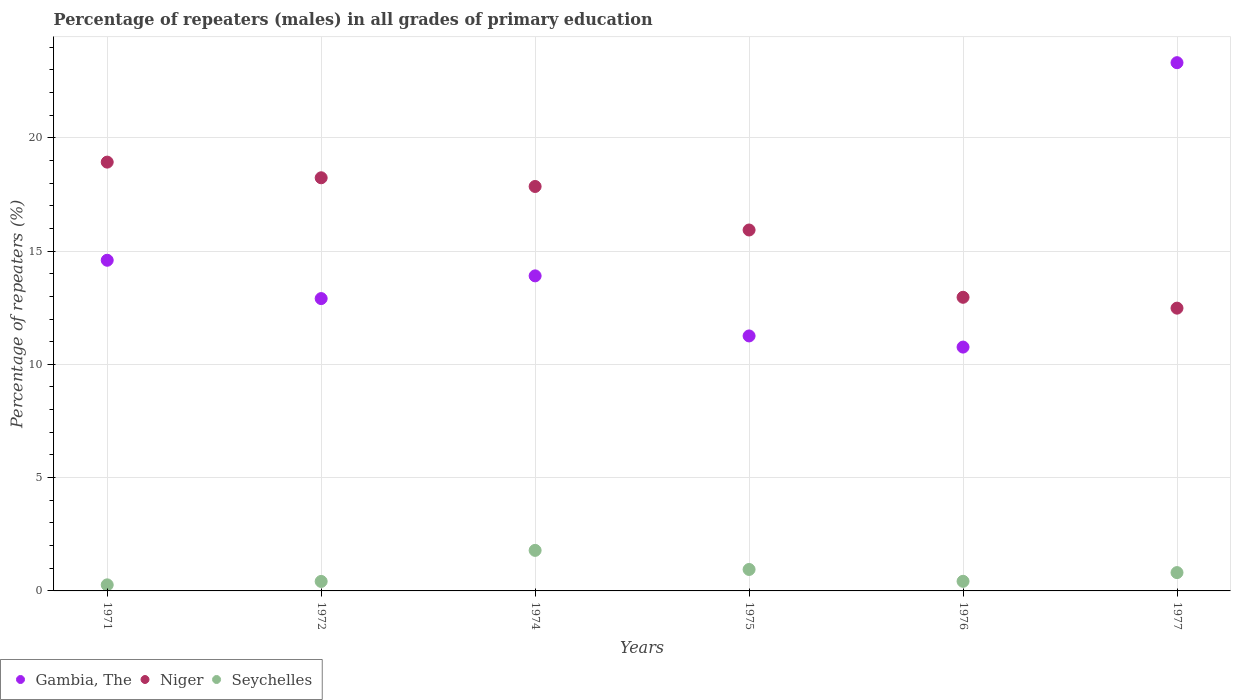What is the percentage of repeaters (males) in Gambia, The in 1976?
Your answer should be compact. 10.76. Across all years, what is the maximum percentage of repeaters (males) in Seychelles?
Ensure brevity in your answer.  1.79. Across all years, what is the minimum percentage of repeaters (males) in Seychelles?
Provide a short and direct response. 0.27. In which year was the percentage of repeaters (males) in Gambia, The maximum?
Make the answer very short. 1977. In which year was the percentage of repeaters (males) in Gambia, The minimum?
Your answer should be compact. 1976. What is the total percentage of repeaters (males) in Gambia, The in the graph?
Make the answer very short. 86.73. What is the difference between the percentage of repeaters (males) in Niger in 1971 and that in 1974?
Make the answer very short. 1.07. What is the difference between the percentage of repeaters (males) in Gambia, The in 1971 and the percentage of repeaters (males) in Niger in 1977?
Make the answer very short. 2.11. What is the average percentage of repeaters (males) in Seychelles per year?
Provide a succinct answer. 0.78. In the year 1976, what is the difference between the percentage of repeaters (males) in Niger and percentage of repeaters (males) in Seychelles?
Make the answer very short. 12.53. In how many years, is the percentage of repeaters (males) in Seychelles greater than 9 %?
Your response must be concise. 0. What is the ratio of the percentage of repeaters (males) in Seychelles in 1976 to that in 1977?
Make the answer very short. 0.52. Is the percentage of repeaters (males) in Gambia, The in 1971 less than that in 1977?
Offer a terse response. Yes. What is the difference between the highest and the second highest percentage of repeaters (males) in Gambia, The?
Keep it short and to the point. 8.72. What is the difference between the highest and the lowest percentage of repeaters (males) in Seychelles?
Offer a terse response. 1.52. In how many years, is the percentage of repeaters (males) in Seychelles greater than the average percentage of repeaters (males) in Seychelles taken over all years?
Offer a terse response. 3. Does the percentage of repeaters (males) in Niger monotonically increase over the years?
Ensure brevity in your answer.  No. How many dotlines are there?
Your response must be concise. 3. How many years are there in the graph?
Your answer should be compact. 6. What is the difference between two consecutive major ticks on the Y-axis?
Make the answer very short. 5. Are the values on the major ticks of Y-axis written in scientific E-notation?
Your answer should be compact. No. Does the graph contain grids?
Give a very brief answer. Yes. How many legend labels are there?
Give a very brief answer. 3. What is the title of the graph?
Ensure brevity in your answer.  Percentage of repeaters (males) in all grades of primary education. What is the label or title of the X-axis?
Offer a very short reply. Years. What is the label or title of the Y-axis?
Keep it short and to the point. Percentage of repeaters (%). What is the Percentage of repeaters (%) of Gambia, The in 1971?
Your answer should be very brief. 14.59. What is the Percentage of repeaters (%) of Niger in 1971?
Keep it short and to the point. 18.92. What is the Percentage of repeaters (%) of Seychelles in 1971?
Keep it short and to the point. 0.27. What is the Percentage of repeaters (%) in Gambia, The in 1972?
Your response must be concise. 12.9. What is the Percentage of repeaters (%) in Niger in 1972?
Ensure brevity in your answer.  18.23. What is the Percentage of repeaters (%) of Seychelles in 1972?
Your answer should be very brief. 0.42. What is the Percentage of repeaters (%) of Gambia, The in 1974?
Provide a succinct answer. 13.9. What is the Percentage of repeaters (%) in Niger in 1974?
Keep it short and to the point. 17.85. What is the Percentage of repeaters (%) of Seychelles in 1974?
Your answer should be compact. 1.79. What is the Percentage of repeaters (%) of Gambia, The in 1975?
Keep it short and to the point. 11.25. What is the Percentage of repeaters (%) of Niger in 1975?
Offer a very short reply. 15.93. What is the Percentage of repeaters (%) in Seychelles in 1975?
Provide a short and direct response. 0.95. What is the Percentage of repeaters (%) in Gambia, The in 1976?
Provide a short and direct response. 10.76. What is the Percentage of repeaters (%) in Niger in 1976?
Give a very brief answer. 12.96. What is the Percentage of repeaters (%) of Seychelles in 1976?
Provide a succinct answer. 0.42. What is the Percentage of repeaters (%) in Gambia, The in 1977?
Ensure brevity in your answer.  23.31. What is the Percentage of repeaters (%) in Niger in 1977?
Provide a short and direct response. 12.48. What is the Percentage of repeaters (%) in Seychelles in 1977?
Keep it short and to the point. 0.81. Across all years, what is the maximum Percentage of repeaters (%) of Gambia, The?
Your response must be concise. 23.31. Across all years, what is the maximum Percentage of repeaters (%) of Niger?
Your answer should be compact. 18.92. Across all years, what is the maximum Percentage of repeaters (%) of Seychelles?
Your answer should be very brief. 1.79. Across all years, what is the minimum Percentage of repeaters (%) of Gambia, The?
Provide a short and direct response. 10.76. Across all years, what is the minimum Percentage of repeaters (%) of Niger?
Give a very brief answer. 12.48. Across all years, what is the minimum Percentage of repeaters (%) of Seychelles?
Ensure brevity in your answer.  0.27. What is the total Percentage of repeaters (%) in Gambia, The in the graph?
Ensure brevity in your answer.  86.73. What is the total Percentage of repeaters (%) of Niger in the graph?
Your answer should be compact. 96.37. What is the total Percentage of repeaters (%) of Seychelles in the graph?
Your response must be concise. 4.66. What is the difference between the Percentage of repeaters (%) of Gambia, The in 1971 and that in 1972?
Keep it short and to the point. 1.69. What is the difference between the Percentage of repeaters (%) of Niger in 1971 and that in 1972?
Give a very brief answer. 0.69. What is the difference between the Percentage of repeaters (%) in Seychelles in 1971 and that in 1972?
Offer a terse response. -0.15. What is the difference between the Percentage of repeaters (%) in Gambia, The in 1971 and that in 1974?
Your answer should be compact. 0.69. What is the difference between the Percentage of repeaters (%) in Niger in 1971 and that in 1974?
Provide a short and direct response. 1.07. What is the difference between the Percentage of repeaters (%) of Seychelles in 1971 and that in 1974?
Your answer should be compact. -1.52. What is the difference between the Percentage of repeaters (%) of Gambia, The in 1971 and that in 1975?
Ensure brevity in your answer.  3.34. What is the difference between the Percentage of repeaters (%) in Niger in 1971 and that in 1975?
Your answer should be compact. 3. What is the difference between the Percentage of repeaters (%) in Seychelles in 1971 and that in 1975?
Offer a very short reply. -0.68. What is the difference between the Percentage of repeaters (%) of Gambia, The in 1971 and that in 1976?
Offer a terse response. 3.83. What is the difference between the Percentage of repeaters (%) of Niger in 1971 and that in 1976?
Keep it short and to the point. 5.97. What is the difference between the Percentage of repeaters (%) in Seychelles in 1971 and that in 1976?
Offer a very short reply. -0.16. What is the difference between the Percentage of repeaters (%) of Gambia, The in 1971 and that in 1977?
Your answer should be very brief. -8.72. What is the difference between the Percentage of repeaters (%) of Niger in 1971 and that in 1977?
Your response must be concise. 6.44. What is the difference between the Percentage of repeaters (%) of Seychelles in 1971 and that in 1977?
Offer a very short reply. -0.54. What is the difference between the Percentage of repeaters (%) in Gambia, The in 1972 and that in 1974?
Your response must be concise. -1. What is the difference between the Percentage of repeaters (%) of Niger in 1972 and that in 1974?
Offer a terse response. 0.38. What is the difference between the Percentage of repeaters (%) of Seychelles in 1972 and that in 1974?
Provide a succinct answer. -1.37. What is the difference between the Percentage of repeaters (%) in Gambia, The in 1972 and that in 1975?
Give a very brief answer. 1.65. What is the difference between the Percentage of repeaters (%) in Niger in 1972 and that in 1975?
Offer a very short reply. 2.3. What is the difference between the Percentage of repeaters (%) of Seychelles in 1972 and that in 1975?
Your response must be concise. -0.53. What is the difference between the Percentage of repeaters (%) of Gambia, The in 1972 and that in 1976?
Provide a short and direct response. 2.14. What is the difference between the Percentage of repeaters (%) in Niger in 1972 and that in 1976?
Offer a terse response. 5.27. What is the difference between the Percentage of repeaters (%) in Seychelles in 1972 and that in 1976?
Make the answer very short. -0. What is the difference between the Percentage of repeaters (%) of Gambia, The in 1972 and that in 1977?
Provide a short and direct response. -10.41. What is the difference between the Percentage of repeaters (%) of Niger in 1972 and that in 1977?
Provide a short and direct response. 5.75. What is the difference between the Percentage of repeaters (%) of Seychelles in 1972 and that in 1977?
Keep it short and to the point. -0.39. What is the difference between the Percentage of repeaters (%) of Gambia, The in 1974 and that in 1975?
Keep it short and to the point. 2.65. What is the difference between the Percentage of repeaters (%) in Niger in 1974 and that in 1975?
Give a very brief answer. 1.92. What is the difference between the Percentage of repeaters (%) of Seychelles in 1974 and that in 1975?
Your answer should be compact. 0.84. What is the difference between the Percentage of repeaters (%) in Gambia, The in 1974 and that in 1976?
Your answer should be very brief. 3.14. What is the difference between the Percentage of repeaters (%) of Niger in 1974 and that in 1976?
Provide a short and direct response. 4.89. What is the difference between the Percentage of repeaters (%) of Seychelles in 1974 and that in 1976?
Give a very brief answer. 1.37. What is the difference between the Percentage of repeaters (%) of Gambia, The in 1974 and that in 1977?
Your answer should be very brief. -9.41. What is the difference between the Percentage of repeaters (%) in Niger in 1974 and that in 1977?
Keep it short and to the point. 5.37. What is the difference between the Percentage of repeaters (%) in Seychelles in 1974 and that in 1977?
Your answer should be compact. 0.98. What is the difference between the Percentage of repeaters (%) of Gambia, The in 1975 and that in 1976?
Provide a short and direct response. 0.49. What is the difference between the Percentage of repeaters (%) of Niger in 1975 and that in 1976?
Your answer should be very brief. 2.97. What is the difference between the Percentage of repeaters (%) in Seychelles in 1975 and that in 1976?
Ensure brevity in your answer.  0.52. What is the difference between the Percentage of repeaters (%) of Gambia, The in 1975 and that in 1977?
Make the answer very short. -12.06. What is the difference between the Percentage of repeaters (%) in Niger in 1975 and that in 1977?
Offer a terse response. 3.45. What is the difference between the Percentage of repeaters (%) in Seychelles in 1975 and that in 1977?
Provide a short and direct response. 0.14. What is the difference between the Percentage of repeaters (%) in Gambia, The in 1976 and that in 1977?
Keep it short and to the point. -12.55. What is the difference between the Percentage of repeaters (%) of Niger in 1976 and that in 1977?
Provide a succinct answer. 0.48. What is the difference between the Percentage of repeaters (%) of Seychelles in 1976 and that in 1977?
Your answer should be very brief. -0.38. What is the difference between the Percentage of repeaters (%) in Gambia, The in 1971 and the Percentage of repeaters (%) in Niger in 1972?
Make the answer very short. -3.64. What is the difference between the Percentage of repeaters (%) in Gambia, The in 1971 and the Percentage of repeaters (%) in Seychelles in 1972?
Your response must be concise. 14.17. What is the difference between the Percentage of repeaters (%) of Niger in 1971 and the Percentage of repeaters (%) of Seychelles in 1972?
Provide a short and direct response. 18.51. What is the difference between the Percentage of repeaters (%) of Gambia, The in 1971 and the Percentage of repeaters (%) of Niger in 1974?
Your answer should be very brief. -3.26. What is the difference between the Percentage of repeaters (%) in Gambia, The in 1971 and the Percentage of repeaters (%) in Seychelles in 1974?
Give a very brief answer. 12.8. What is the difference between the Percentage of repeaters (%) of Niger in 1971 and the Percentage of repeaters (%) of Seychelles in 1974?
Offer a terse response. 17.14. What is the difference between the Percentage of repeaters (%) of Gambia, The in 1971 and the Percentage of repeaters (%) of Niger in 1975?
Keep it short and to the point. -1.34. What is the difference between the Percentage of repeaters (%) in Gambia, The in 1971 and the Percentage of repeaters (%) in Seychelles in 1975?
Offer a terse response. 13.65. What is the difference between the Percentage of repeaters (%) in Niger in 1971 and the Percentage of repeaters (%) in Seychelles in 1975?
Provide a succinct answer. 17.98. What is the difference between the Percentage of repeaters (%) in Gambia, The in 1971 and the Percentage of repeaters (%) in Niger in 1976?
Provide a short and direct response. 1.63. What is the difference between the Percentage of repeaters (%) of Gambia, The in 1971 and the Percentage of repeaters (%) of Seychelles in 1976?
Offer a very short reply. 14.17. What is the difference between the Percentage of repeaters (%) of Niger in 1971 and the Percentage of repeaters (%) of Seychelles in 1976?
Make the answer very short. 18.5. What is the difference between the Percentage of repeaters (%) of Gambia, The in 1971 and the Percentage of repeaters (%) of Niger in 1977?
Ensure brevity in your answer.  2.11. What is the difference between the Percentage of repeaters (%) in Gambia, The in 1971 and the Percentage of repeaters (%) in Seychelles in 1977?
Give a very brief answer. 13.78. What is the difference between the Percentage of repeaters (%) in Niger in 1971 and the Percentage of repeaters (%) in Seychelles in 1977?
Your answer should be compact. 18.12. What is the difference between the Percentage of repeaters (%) of Gambia, The in 1972 and the Percentage of repeaters (%) of Niger in 1974?
Keep it short and to the point. -4.95. What is the difference between the Percentage of repeaters (%) in Gambia, The in 1972 and the Percentage of repeaters (%) in Seychelles in 1974?
Provide a succinct answer. 11.11. What is the difference between the Percentage of repeaters (%) of Niger in 1972 and the Percentage of repeaters (%) of Seychelles in 1974?
Your answer should be very brief. 16.44. What is the difference between the Percentage of repeaters (%) of Gambia, The in 1972 and the Percentage of repeaters (%) of Niger in 1975?
Your response must be concise. -3.03. What is the difference between the Percentage of repeaters (%) in Gambia, The in 1972 and the Percentage of repeaters (%) in Seychelles in 1975?
Keep it short and to the point. 11.96. What is the difference between the Percentage of repeaters (%) of Niger in 1972 and the Percentage of repeaters (%) of Seychelles in 1975?
Your answer should be very brief. 17.29. What is the difference between the Percentage of repeaters (%) of Gambia, The in 1972 and the Percentage of repeaters (%) of Niger in 1976?
Your answer should be very brief. -0.06. What is the difference between the Percentage of repeaters (%) of Gambia, The in 1972 and the Percentage of repeaters (%) of Seychelles in 1976?
Provide a short and direct response. 12.48. What is the difference between the Percentage of repeaters (%) of Niger in 1972 and the Percentage of repeaters (%) of Seychelles in 1976?
Your response must be concise. 17.81. What is the difference between the Percentage of repeaters (%) of Gambia, The in 1972 and the Percentage of repeaters (%) of Niger in 1977?
Your answer should be compact. 0.42. What is the difference between the Percentage of repeaters (%) of Gambia, The in 1972 and the Percentage of repeaters (%) of Seychelles in 1977?
Ensure brevity in your answer.  12.09. What is the difference between the Percentage of repeaters (%) in Niger in 1972 and the Percentage of repeaters (%) in Seychelles in 1977?
Your answer should be very brief. 17.43. What is the difference between the Percentage of repeaters (%) in Gambia, The in 1974 and the Percentage of repeaters (%) in Niger in 1975?
Your response must be concise. -2.02. What is the difference between the Percentage of repeaters (%) in Gambia, The in 1974 and the Percentage of repeaters (%) in Seychelles in 1975?
Provide a short and direct response. 12.96. What is the difference between the Percentage of repeaters (%) of Niger in 1974 and the Percentage of repeaters (%) of Seychelles in 1975?
Provide a short and direct response. 16.9. What is the difference between the Percentage of repeaters (%) in Gambia, The in 1974 and the Percentage of repeaters (%) in Niger in 1976?
Give a very brief answer. 0.95. What is the difference between the Percentage of repeaters (%) of Gambia, The in 1974 and the Percentage of repeaters (%) of Seychelles in 1976?
Your response must be concise. 13.48. What is the difference between the Percentage of repeaters (%) of Niger in 1974 and the Percentage of repeaters (%) of Seychelles in 1976?
Provide a short and direct response. 17.43. What is the difference between the Percentage of repeaters (%) of Gambia, The in 1974 and the Percentage of repeaters (%) of Niger in 1977?
Your answer should be very brief. 1.42. What is the difference between the Percentage of repeaters (%) of Gambia, The in 1974 and the Percentage of repeaters (%) of Seychelles in 1977?
Provide a succinct answer. 13.1. What is the difference between the Percentage of repeaters (%) in Niger in 1974 and the Percentage of repeaters (%) in Seychelles in 1977?
Your answer should be very brief. 17.04. What is the difference between the Percentage of repeaters (%) in Gambia, The in 1975 and the Percentage of repeaters (%) in Niger in 1976?
Ensure brevity in your answer.  -1.71. What is the difference between the Percentage of repeaters (%) of Gambia, The in 1975 and the Percentage of repeaters (%) of Seychelles in 1976?
Keep it short and to the point. 10.83. What is the difference between the Percentage of repeaters (%) in Niger in 1975 and the Percentage of repeaters (%) in Seychelles in 1976?
Make the answer very short. 15.5. What is the difference between the Percentage of repeaters (%) of Gambia, The in 1975 and the Percentage of repeaters (%) of Niger in 1977?
Make the answer very short. -1.23. What is the difference between the Percentage of repeaters (%) in Gambia, The in 1975 and the Percentage of repeaters (%) in Seychelles in 1977?
Give a very brief answer. 10.44. What is the difference between the Percentage of repeaters (%) of Niger in 1975 and the Percentage of repeaters (%) of Seychelles in 1977?
Your response must be concise. 15.12. What is the difference between the Percentage of repeaters (%) of Gambia, The in 1976 and the Percentage of repeaters (%) of Niger in 1977?
Offer a very short reply. -1.72. What is the difference between the Percentage of repeaters (%) of Gambia, The in 1976 and the Percentage of repeaters (%) of Seychelles in 1977?
Provide a succinct answer. 9.95. What is the difference between the Percentage of repeaters (%) in Niger in 1976 and the Percentage of repeaters (%) in Seychelles in 1977?
Ensure brevity in your answer.  12.15. What is the average Percentage of repeaters (%) in Gambia, The per year?
Keep it short and to the point. 14.45. What is the average Percentage of repeaters (%) in Niger per year?
Your answer should be compact. 16.06. What is the average Percentage of repeaters (%) in Seychelles per year?
Your answer should be compact. 0.78. In the year 1971, what is the difference between the Percentage of repeaters (%) in Gambia, The and Percentage of repeaters (%) in Niger?
Give a very brief answer. -4.33. In the year 1971, what is the difference between the Percentage of repeaters (%) in Gambia, The and Percentage of repeaters (%) in Seychelles?
Your response must be concise. 14.33. In the year 1971, what is the difference between the Percentage of repeaters (%) in Niger and Percentage of repeaters (%) in Seychelles?
Ensure brevity in your answer.  18.66. In the year 1972, what is the difference between the Percentage of repeaters (%) in Gambia, The and Percentage of repeaters (%) in Niger?
Keep it short and to the point. -5.33. In the year 1972, what is the difference between the Percentage of repeaters (%) of Gambia, The and Percentage of repeaters (%) of Seychelles?
Your answer should be compact. 12.48. In the year 1972, what is the difference between the Percentage of repeaters (%) in Niger and Percentage of repeaters (%) in Seychelles?
Give a very brief answer. 17.81. In the year 1974, what is the difference between the Percentage of repeaters (%) of Gambia, The and Percentage of repeaters (%) of Niger?
Ensure brevity in your answer.  -3.95. In the year 1974, what is the difference between the Percentage of repeaters (%) in Gambia, The and Percentage of repeaters (%) in Seychelles?
Keep it short and to the point. 12.12. In the year 1974, what is the difference between the Percentage of repeaters (%) in Niger and Percentage of repeaters (%) in Seychelles?
Offer a very short reply. 16.06. In the year 1975, what is the difference between the Percentage of repeaters (%) of Gambia, The and Percentage of repeaters (%) of Niger?
Your answer should be compact. -4.68. In the year 1975, what is the difference between the Percentage of repeaters (%) of Gambia, The and Percentage of repeaters (%) of Seychelles?
Make the answer very short. 10.31. In the year 1975, what is the difference between the Percentage of repeaters (%) of Niger and Percentage of repeaters (%) of Seychelles?
Make the answer very short. 14.98. In the year 1976, what is the difference between the Percentage of repeaters (%) in Gambia, The and Percentage of repeaters (%) in Niger?
Offer a terse response. -2.2. In the year 1976, what is the difference between the Percentage of repeaters (%) in Gambia, The and Percentage of repeaters (%) in Seychelles?
Keep it short and to the point. 10.34. In the year 1976, what is the difference between the Percentage of repeaters (%) of Niger and Percentage of repeaters (%) of Seychelles?
Give a very brief answer. 12.54. In the year 1977, what is the difference between the Percentage of repeaters (%) in Gambia, The and Percentage of repeaters (%) in Niger?
Provide a short and direct response. 10.83. In the year 1977, what is the difference between the Percentage of repeaters (%) of Gambia, The and Percentage of repeaters (%) of Seychelles?
Give a very brief answer. 22.5. In the year 1977, what is the difference between the Percentage of repeaters (%) in Niger and Percentage of repeaters (%) in Seychelles?
Your answer should be compact. 11.67. What is the ratio of the Percentage of repeaters (%) of Gambia, The in 1971 to that in 1972?
Offer a very short reply. 1.13. What is the ratio of the Percentage of repeaters (%) of Niger in 1971 to that in 1972?
Ensure brevity in your answer.  1.04. What is the ratio of the Percentage of repeaters (%) of Seychelles in 1971 to that in 1972?
Provide a succinct answer. 0.64. What is the ratio of the Percentage of repeaters (%) of Gambia, The in 1971 to that in 1974?
Offer a terse response. 1.05. What is the ratio of the Percentage of repeaters (%) of Niger in 1971 to that in 1974?
Offer a very short reply. 1.06. What is the ratio of the Percentage of repeaters (%) in Seychelles in 1971 to that in 1974?
Keep it short and to the point. 0.15. What is the ratio of the Percentage of repeaters (%) of Gambia, The in 1971 to that in 1975?
Make the answer very short. 1.3. What is the ratio of the Percentage of repeaters (%) in Niger in 1971 to that in 1975?
Provide a succinct answer. 1.19. What is the ratio of the Percentage of repeaters (%) in Seychelles in 1971 to that in 1975?
Keep it short and to the point. 0.28. What is the ratio of the Percentage of repeaters (%) in Gambia, The in 1971 to that in 1976?
Your response must be concise. 1.36. What is the ratio of the Percentage of repeaters (%) in Niger in 1971 to that in 1976?
Provide a short and direct response. 1.46. What is the ratio of the Percentage of repeaters (%) of Seychelles in 1971 to that in 1976?
Your answer should be very brief. 0.63. What is the ratio of the Percentage of repeaters (%) of Gambia, The in 1971 to that in 1977?
Offer a very short reply. 0.63. What is the ratio of the Percentage of repeaters (%) of Niger in 1971 to that in 1977?
Offer a terse response. 1.52. What is the ratio of the Percentage of repeaters (%) of Seychelles in 1971 to that in 1977?
Keep it short and to the point. 0.33. What is the ratio of the Percentage of repeaters (%) in Gambia, The in 1972 to that in 1974?
Provide a short and direct response. 0.93. What is the ratio of the Percentage of repeaters (%) in Niger in 1972 to that in 1974?
Offer a terse response. 1.02. What is the ratio of the Percentage of repeaters (%) in Seychelles in 1972 to that in 1974?
Provide a succinct answer. 0.23. What is the ratio of the Percentage of repeaters (%) in Gambia, The in 1972 to that in 1975?
Offer a terse response. 1.15. What is the ratio of the Percentage of repeaters (%) in Niger in 1972 to that in 1975?
Provide a succinct answer. 1.14. What is the ratio of the Percentage of repeaters (%) in Seychelles in 1972 to that in 1975?
Ensure brevity in your answer.  0.44. What is the ratio of the Percentage of repeaters (%) in Gambia, The in 1972 to that in 1976?
Give a very brief answer. 1.2. What is the ratio of the Percentage of repeaters (%) of Niger in 1972 to that in 1976?
Your response must be concise. 1.41. What is the ratio of the Percentage of repeaters (%) in Seychelles in 1972 to that in 1976?
Your answer should be compact. 0.99. What is the ratio of the Percentage of repeaters (%) of Gambia, The in 1972 to that in 1977?
Your answer should be compact. 0.55. What is the ratio of the Percentage of repeaters (%) of Niger in 1972 to that in 1977?
Offer a terse response. 1.46. What is the ratio of the Percentage of repeaters (%) of Seychelles in 1972 to that in 1977?
Give a very brief answer. 0.52. What is the ratio of the Percentage of repeaters (%) of Gambia, The in 1974 to that in 1975?
Keep it short and to the point. 1.24. What is the ratio of the Percentage of repeaters (%) of Niger in 1974 to that in 1975?
Make the answer very short. 1.12. What is the ratio of the Percentage of repeaters (%) in Seychelles in 1974 to that in 1975?
Make the answer very short. 1.89. What is the ratio of the Percentage of repeaters (%) of Gambia, The in 1974 to that in 1976?
Offer a terse response. 1.29. What is the ratio of the Percentage of repeaters (%) of Niger in 1974 to that in 1976?
Keep it short and to the point. 1.38. What is the ratio of the Percentage of repeaters (%) in Seychelles in 1974 to that in 1976?
Your response must be concise. 4.22. What is the ratio of the Percentage of repeaters (%) of Gambia, The in 1974 to that in 1977?
Ensure brevity in your answer.  0.6. What is the ratio of the Percentage of repeaters (%) of Niger in 1974 to that in 1977?
Keep it short and to the point. 1.43. What is the ratio of the Percentage of repeaters (%) of Seychelles in 1974 to that in 1977?
Provide a succinct answer. 2.21. What is the ratio of the Percentage of repeaters (%) of Gambia, The in 1975 to that in 1976?
Offer a very short reply. 1.05. What is the ratio of the Percentage of repeaters (%) of Niger in 1975 to that in 1976?
Offer a terse response. 1.23. What is the ratio of the Percentage of repeaters (%) in Seychelles in 1975 to that in 1976?
Give a very brief answer. 2.23. What is the ratio of the Percentage of repeaters (%) of Gambia, The in 1975 to that in 1977?
Keep it short and to the point. 0.48. What is the ratio of the Percentage of repeaters (%) of Niger in 1975 to that in 1977?
Offer a very short reply. 1.28. What is the ratio of the Percentage of repeaters (%) of Seychelles in 1975 to that in 1977?
Give a very brief answer. 1.17. What is the ratio of the Percentage of repeaters (%) in Gambia, The in 1976 to that in 1977?
Offer a terse response. 0.46. What is the ratio of the Percentage of repeaters (%) in Niger in 1976 to that in 1977?
Provide a succinct answer. 1.04. What is the ratio of the Percentage of repeaters (%) in Seychelles in 1976 to that in 1977?
Make the answer very short. 0.52. What is the difference between the highest and the second highest Percentage of repeaters (%) in Gambia, The?
Keep it short and to the point. 8.72. What is the difference between the highest and the second highest Percentage of repeaters (%) of Niger?
Ensure brevity in your answer.  0.69. What is the difference between the highest and the second highest Percentage of repeaters (%) of Seychelles?
Your answer should be very brief. 0.84. What is the difference between the highest and the lowest Percentage of repeaters (%) in Gambia, The?
Provide a short and direct response. 12.55. What is the difference between the highest and the lowest Percentage of repeaters (%) of Niger?
Provide a succinct answer. 6.44. What is the difference between the highest and the lowest Percentage of repeaters (%) in Seychelles?
Your answer should be compact. 1.52. 